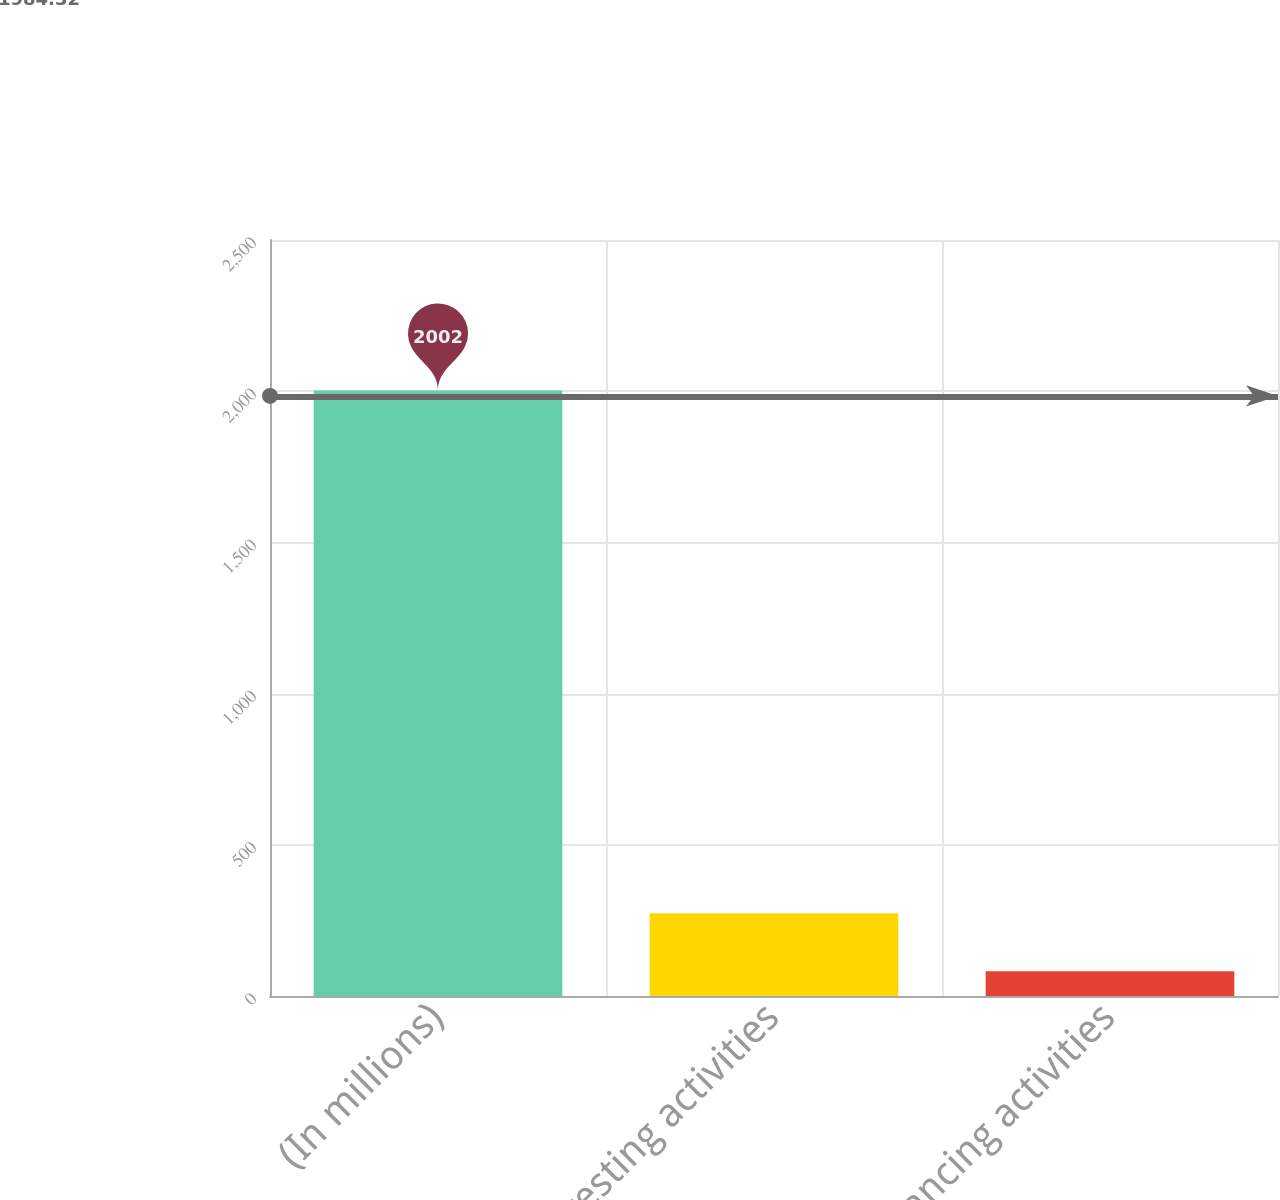Convert chart. <chart><loc_0><loc_0><loc_500><loc_500><bar_chart><fcel>(In millions)<fcel>Investing activities<fcel>Financing activities<nl><fcel>2002<fcel>273.64<fcel>81.6<nl></chart> 